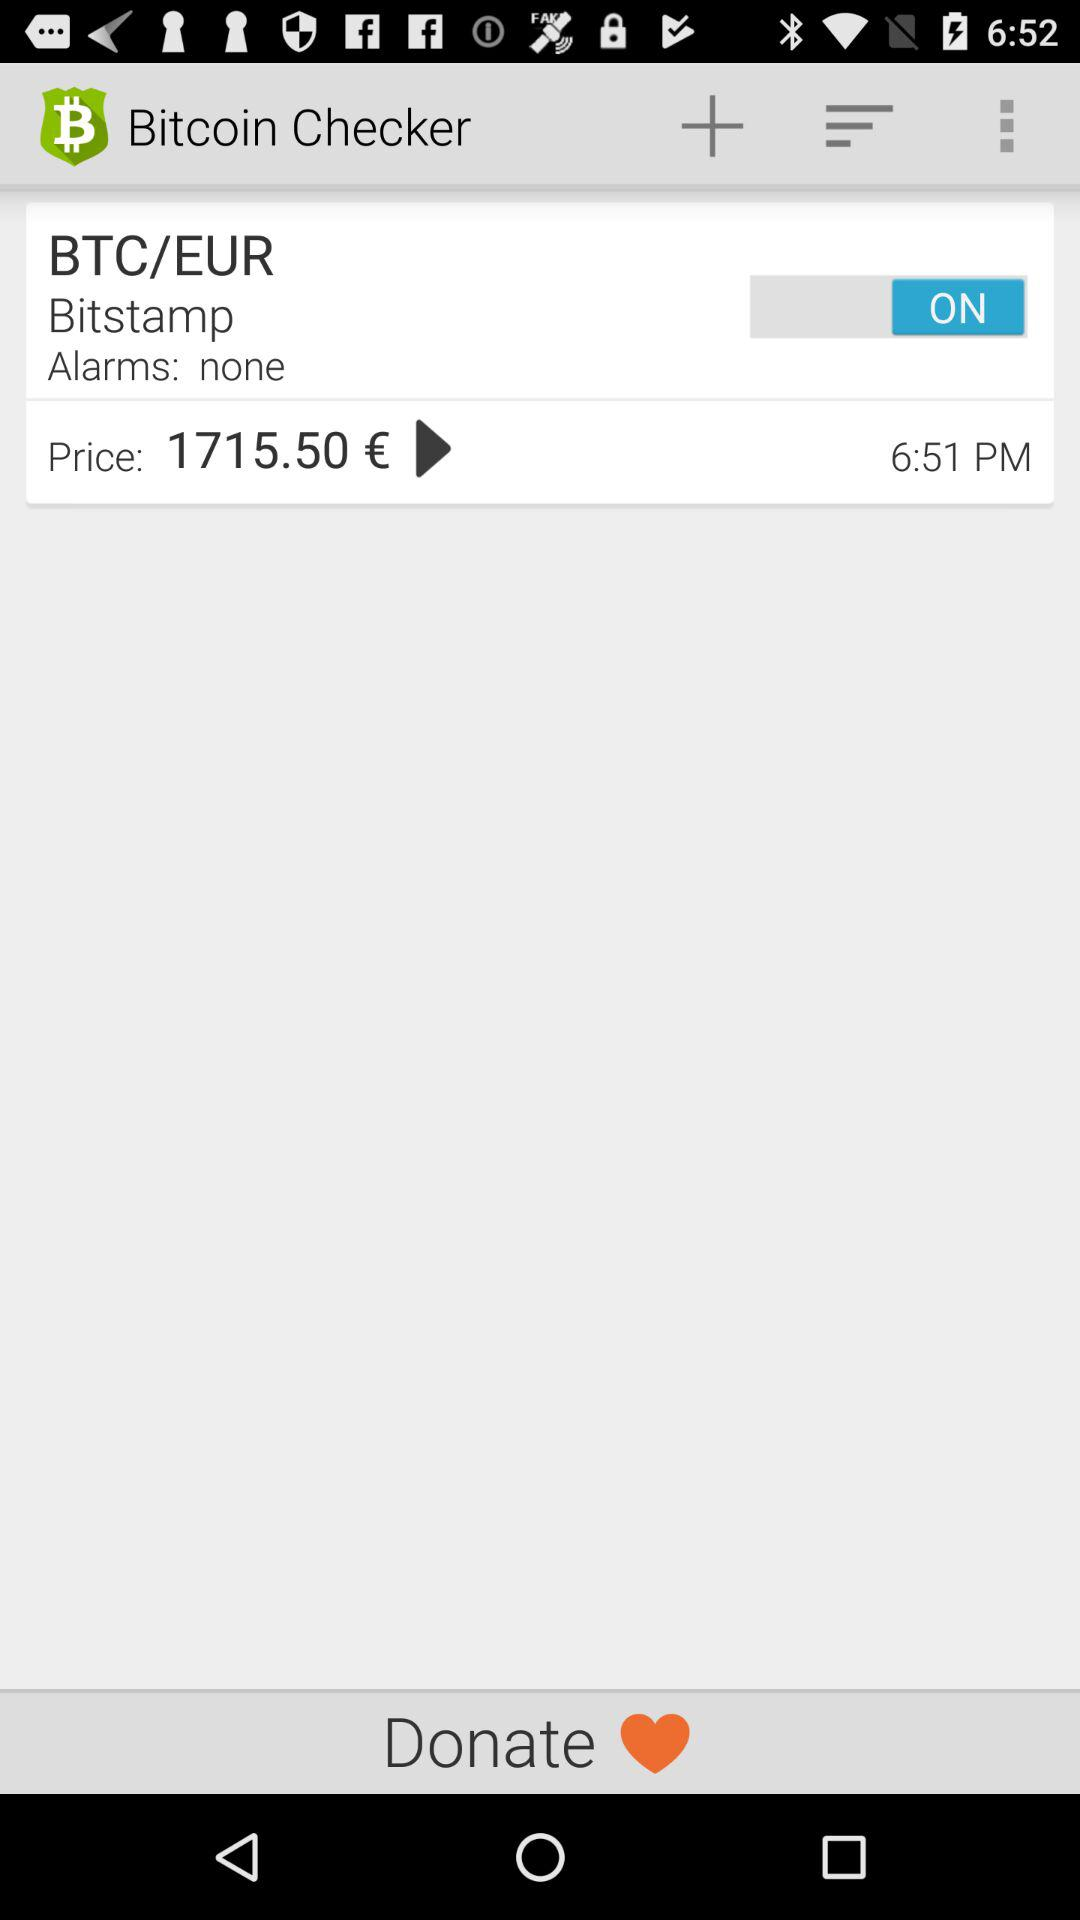At what time was the conversion rate of BTC/EUR 1715.50 euros? The conversion rate of BTC/EUR was 1715.50 euros at 6:51 PM. 